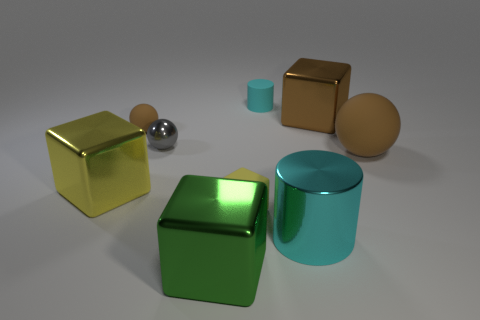Add 1 yellow metal objects. How many objects exist? 10 Subtract all cylinders. How many objects are left? 7 Subtract 1 cyan cylinders. How many objects are left? 8 Subtract all blue rubber cylinders. Subtract all tiny yellow matte things. How many objects are left? 8 Add 9 large cylinders. How many large cylinders are left? 10 Add 9 large yellow metallic blocks. How many large yellow metallic blocks exist? 10 